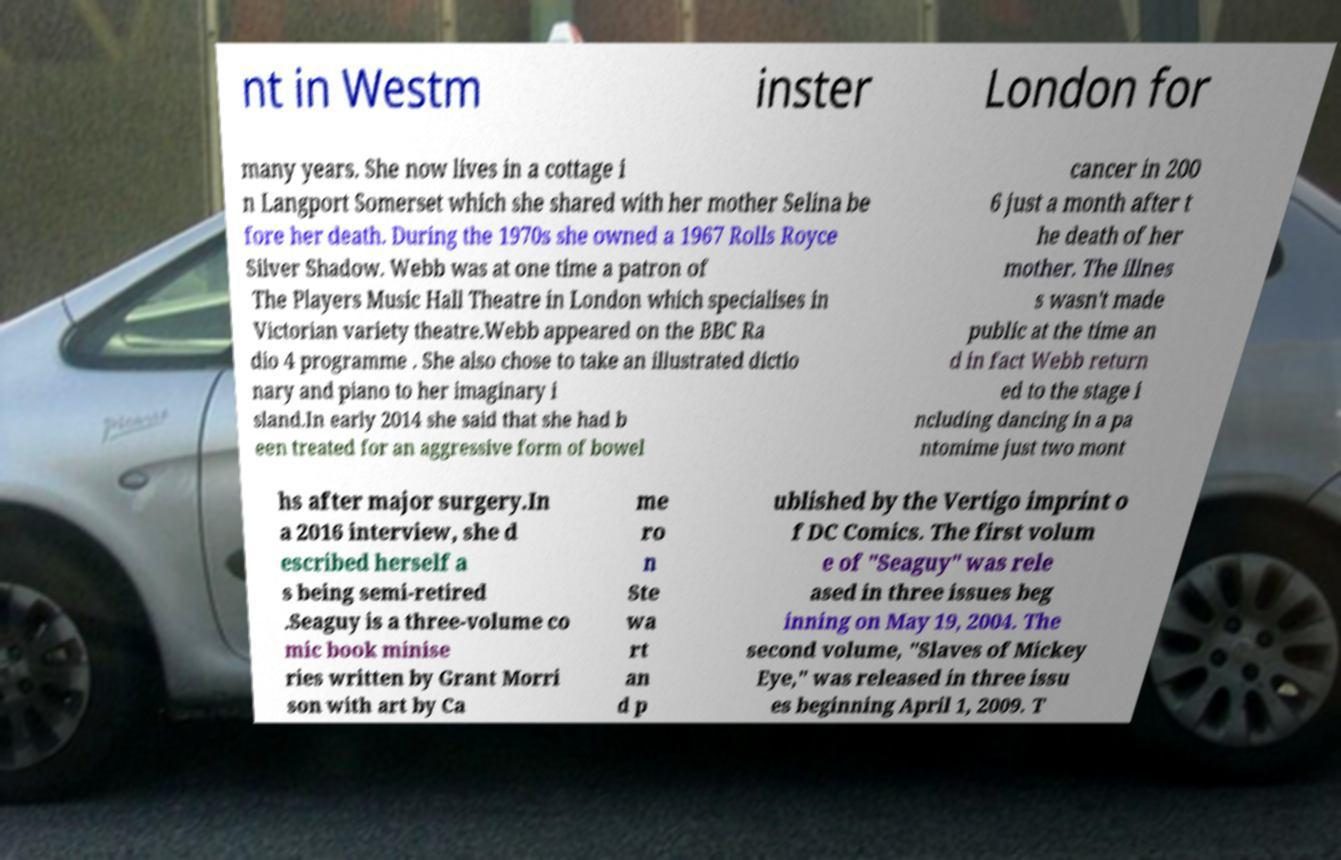Can you accurately transcribe the text from the provided image for me? nt in Westm inster London for many years. She now lives in a cottage i n Langport Somerset which she shared with her mother Selina be fore her death. During the 1970s she owned a 1967 Rolls Royce Silver Shadow. Webb was at one time a patron of The Players Music Hall Theatre in London which specialises in Victorian variety theatre.Webb appeared on the BBC Ra dio 4 programme . She also chose to take an illustrated dictio nary and piano to her imaginary i sland.In early 2014 she said that she had b een treated for an aggressive form of bowel cancer in 200 6 just a month after t he death of her mother. The illnes s wasn't made public at the time an d in fact Webb return ed to the stage i ncluding dancing in a pa ntomime just two mont hs after major surgery.In a 2016 interview, she d escribed herself a s being semi-retired .Seaguy is a three-volume co mic book minise ries written by Grant Morri son with art by Ca me ro n Ste wa rt an d p ublished by the Vertigo imprint o f DC Comics. The first volum e of "Seaguy" was rele ased in three issues beg inning on May 19, 2004. The second volume, "Slaves of Mickey Eye," was released in three issu es beginning April 1, 2009. T 